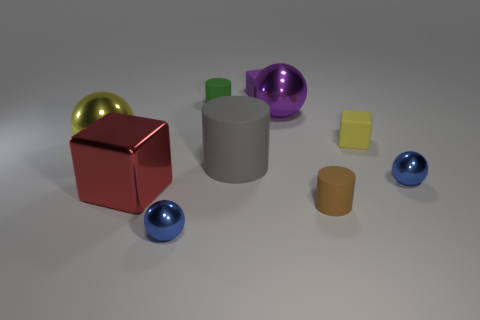Does the tiny metallic sphere that is on the right side of the large gray cylinder have the same color as the tiny metal thing on the left side of the purple rubber cube?
Your response must be concise. Yes. There is a metallic object that is behind the tiny yellow rubber block; what size is it?
Provide a short and direct response. Large. There is a tiny ball that is on the right side of the cylinder to the left of the gray thing; how many tiny metal spheres are in front of it?
Your answer should be very brief. 1. Does the large rubber object have the same color as the metallic block?
Provide a short and direct response. No. What number of metallic things are behind the gray matte cylinder and to the left of the tiny green cylinder?
Ensure brevity in your answer.  1. What is the shape of the tiny rubber object that is in front of the big red block?
Offer a very short reply. Cylinder. Is the number of yellow matte blocks that are to the right of the large metal cube less than the number of tiny purple matte things that are in front of the tiny green rubber cylinder?
Your response must be concise. No. Are the tiny object on the right side of the tiny yellow object and the small cylinder in front of the big yellow shiny ball made of the same material?
Offer a terse response. No. The green matte object has what shape?
Make the answer very short. Cylinder. Is the number of purple matte cubes to the right of the yellow matte object greater than the number of large gray rubber things that are behind the yellow metal object?
Make the answer very short. No. 